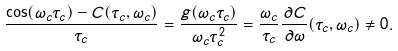<formula> <loc_0><loc_0><loc_500><loc_500>\frac { \cos ( \omega _ { c } \tau _ { c } ) - C ( \tau _ { c } , \omega _ { c } ) } { \tau _ { c } } = \frac { g ( \omega _ { c } \tau _ { c } ) } { \omega _ { c } \tau _ { c } ^ { 2 } } = \frac { \omega _ { c } } { \tau _ { c } } \frac { \partial C } { \partial \omega } ( \tau _ { c } , \omega _ { c } ) \neq 0 .</formula> 